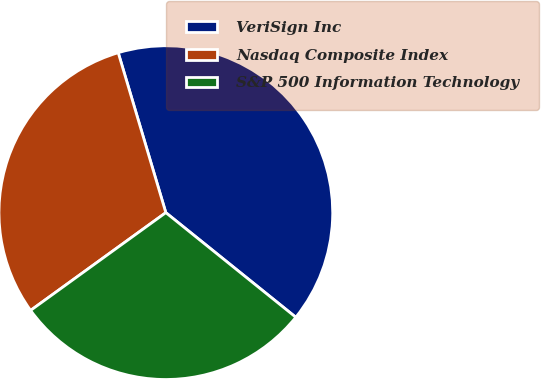<chart> <loc_0><loc_0><loc_500><loc_500><pie_chart><fcel>VeriSign Inc<fcel>Nasdaq Composite Index<fcel>S&P 500 Information Technology<nl><fcel>40.39%<fcel>30.36%<fcel>29.25%<nl></chart> 